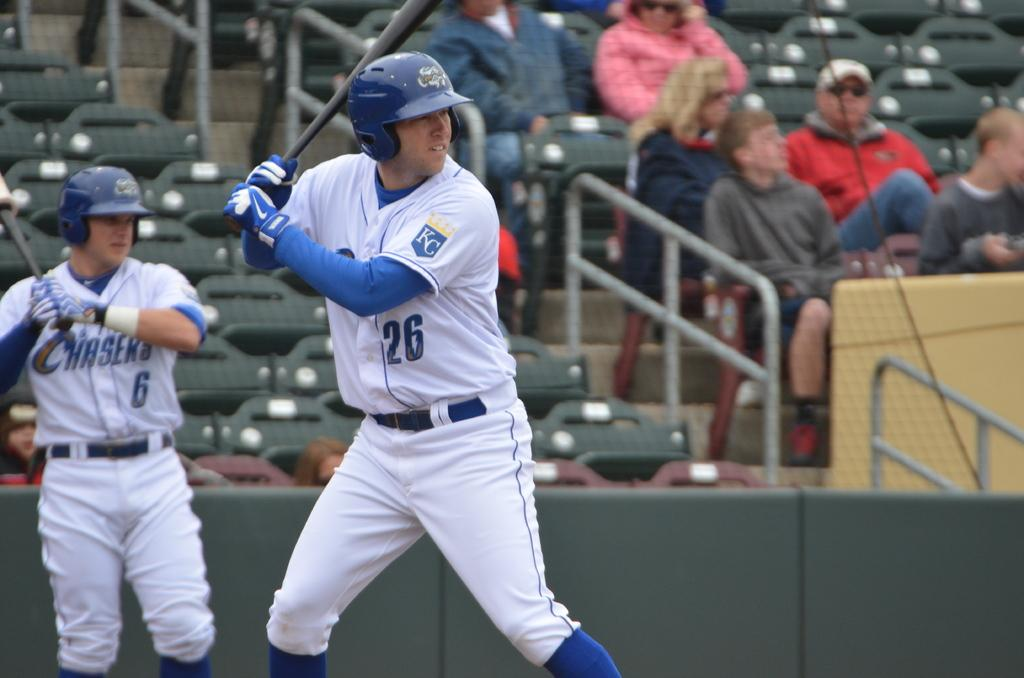What activity are the two people in the image engaged in? The two people in the image are playing baseball. Can you describe the seating arrangement in the image? There are people sitting on chairs in the image. What type of barrier is present in the image? There is a metal fence in the image. Are there any architectural features visible in the image? Yes, there are stairs in the image. How many beetles can be seen crawling on the baseball players in the image? There are no beetles present in the image; it features two people playing baseball and other elements mentioned in the conversation. 